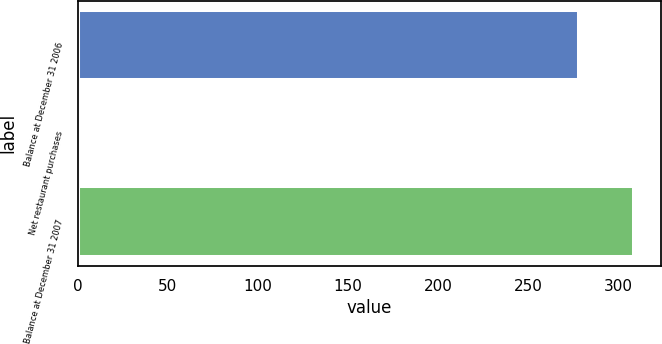Convert chart. <chart><loc_0><loc_0><loc_500><loc_500><bar_chart><fcel>Balance at December 31 2006<fcel>Net restaurant purchases<fcel>Balance at December 31 2007<nl><fcel>277.9<fcel>1.2<fcel>308.39<nl></chart> 